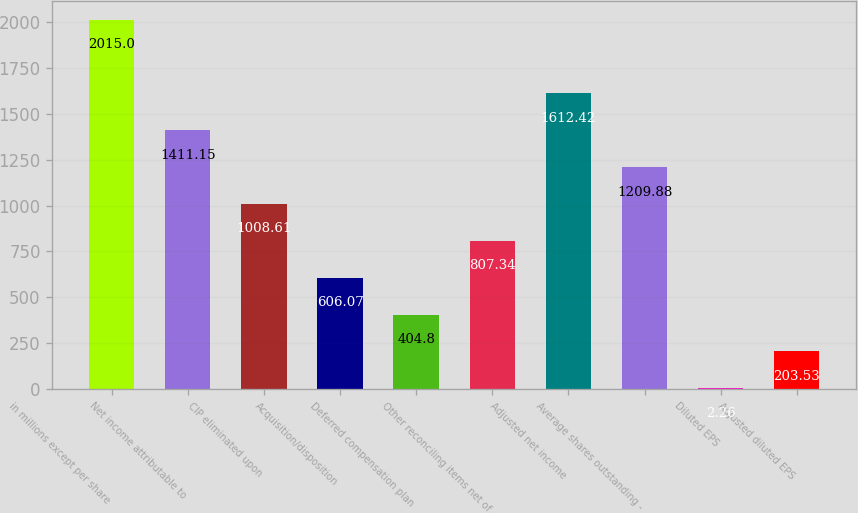Convert chart to OTSL. <chart><loc_0><loc_0><loc_500><loc_500><bar_chart><fcel>in millions except per share<fcel>Net income attributable to<fcel>CIP eliminated upon<fcel>Acquisition/disposition<fcel>Deferred compensation plan<fcel>Other reconciling items net of<fcel>Adjusted net income<fcel>Average shares outstanding -<fcel>Diluted EPS<fcel>Adjusted diluted EPS<nl><fcel>2015<fcel>1411.15<fcel>1008.61<fcel>606.07<fcel>404.8<fcel>807.34<fcel>1612.42<fcel>1209.88<fcel>2.26<fcel>203.53<nl></chart> 